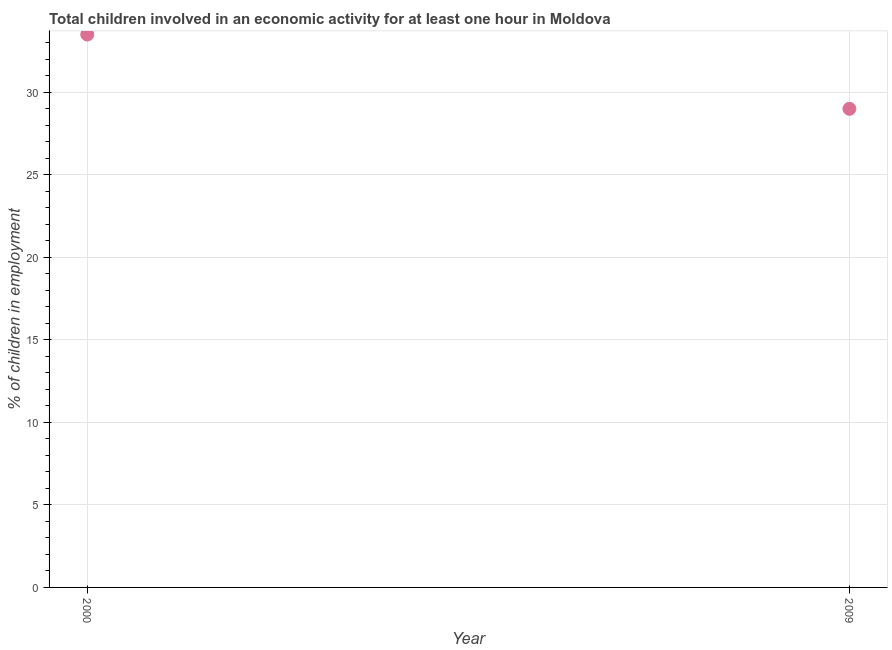What is the percentage of children in employment in 2000?
Your answer should be very brief. 33.5. Across all years, what is the maximum percentage of children in employment?
Provide a short and direct response. 33.5. Across all years, what is the minimum percentage of children in employment?
Give a very brief answer. 29. In which year was the percentage of children in employment minimum?
Provide a short and direct response. 2009. What is the sum of the percentage of children in employment?
Offer a very short reply. 62.5. What is the average percentage of children in employment per year?
Your response must be concise. 31.25. What is the median percentage of children in employment?
Offer a terse response. 31.25. In how many years, is the percentage of children in employment greater than 26 %?
Your response must be concise. 2. What is the ratio of the percentage of children in employment in 2000 to that in 2009?
Keep it short and to the point. 1.16. Is the percentage of children in employment in 2000 less than that in 2009?
Keep it short and to the point. No. In how many years, is the percentage of children in employment greater than the average percentage of children in employment taken over all years?
Your response must be concise. 1. How many dotlines are there?
Keep it short and to the point. 1. What is the difference between two consecutive major ticks on the Y-axis?
Give a very brief answer. 5. Does the graph contain any zero values?
Provide a short and direct response. No. What is the title of the graph?
Your response must be concise. Total children involved in an economic activity for at least one hour in Moldova. What is the label or title of the Y-axis?
Keep it short and to the point. % of children in employment. What is the % of children in employment in 2000?
Keep it short and to the point. 33.5. What is the difference between the % of children in employment in 2000 and 2009?
Your answer should be very brief. 4.5. What is the ratio of the % of children in employment in 2000 to that in 2009?
Make the answer very short. 1.16. 